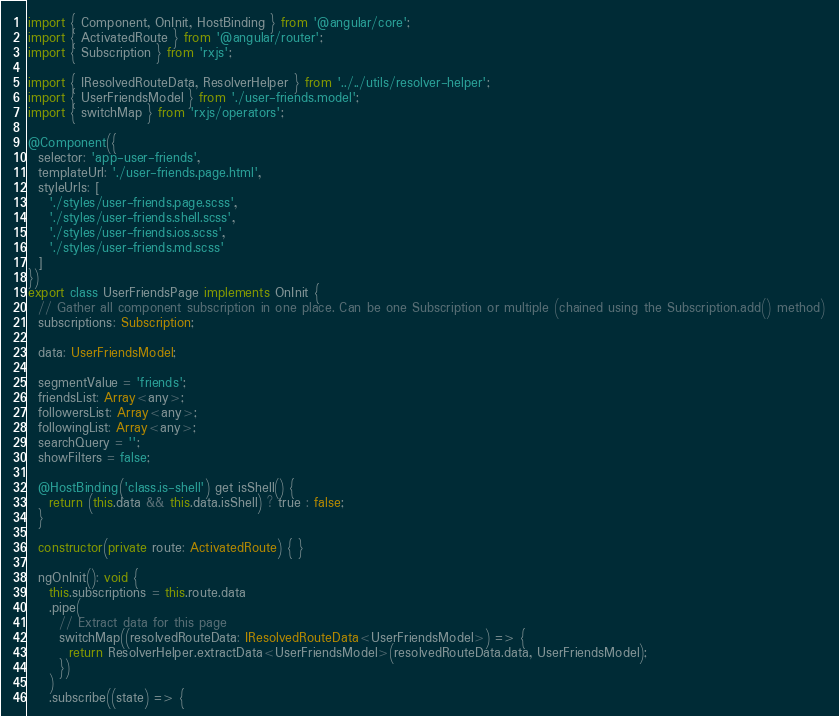<code> <loc_0><loc_0><loc_500><loc_500><_TypeScript_>import { Component, OnInit, HostBinding } from '@angular/core';
import { ActivatedRoute } from '@angular/router';
import { Subscription } from 'rxjs';

import { IResolvedRouteData, ResolverHelper } from '../../utils/resolver-helper';
import { UserFriendsModel } from './user-friends.model';
import { switchMap } from 'rxjs/operators';

@Component({
  selector: 'app-user-friends',
  templateUrl: './user-friends.page.html',
  styleUrls: [
    './styles/user-friends.page.scss',
    './styles/user-friends.shell.scss',
    './styles/user-friends.ios.scss',
    './styles/user-friends.md.scss'
  ]
})
export class UserFriendsPage implements OnInit {
  // Gather all component subscription in one place. Can be one Subscription or multiple (chained using the Subscription.add() method)
  subscriptions: Subscription;

  data: UserFriendsModel;

  segmentValue = 'friends';
  friendsList: Array<any>;
  followersList: Array<any>;
  followingList: Array<any>;
  searchQuery = '';
  showFilters = false;

  @HostBinding('class.is-shell') get isShell() {
    return (this.data && this.data.isShell) ? true : false;
  }

  constructor(private route: ActivatedRoute) { }

  ngOnInit(): void {
    this.subscriptions = this.route.data
    .pipe(
      // Extract data for this page
      switchMap((resolvedRouteData: IResolvedRouteData<UserFriendsModel>) => {
        return ResolverHelper.extractData<UserFriendsModel>(resolvedRouteData.data, UserFriendsModel);
      })
    )
    .subscribe((state) => {</code> 